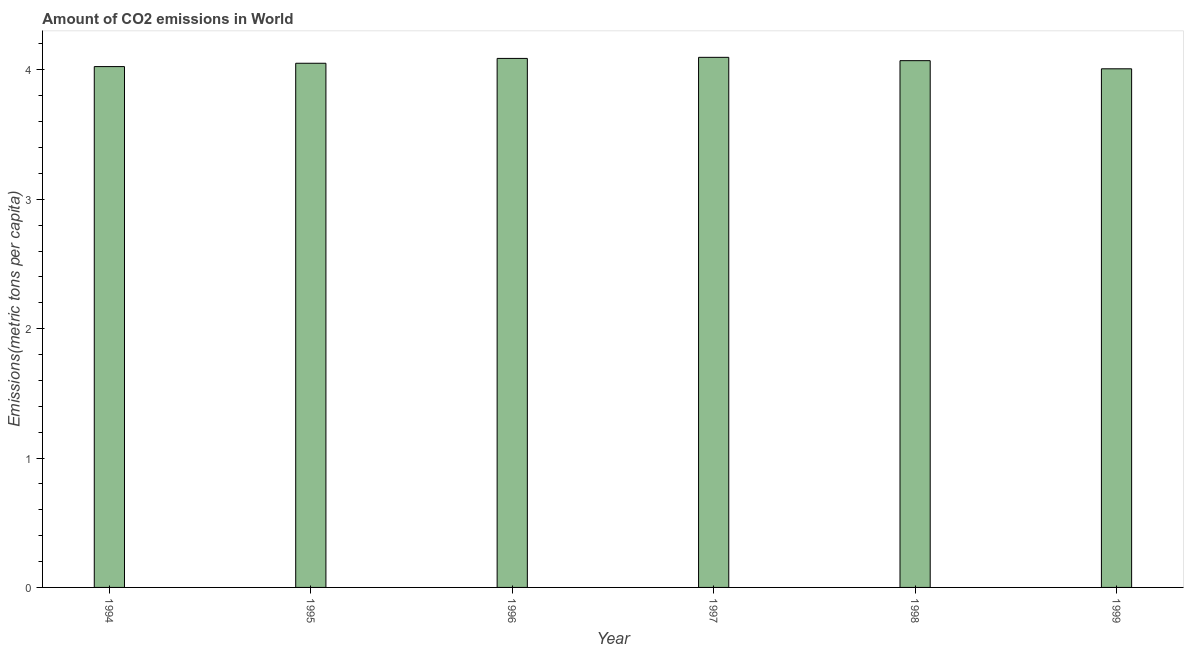Does the graph contain any zero values?
Your answer should be very brief. No. What is the title of the graph?
Give a very brief answer. Amount of CO2 emissions in World. What is the label or title of the X-axis?
Your answer should be compact. Year. What is the label or title of the Y-axis?
Your response must be concise. Emissions(metric tons per capita). What is the amount of co2 emissions in 1995?
Provide a succinct answer. 4.05. Across all years, what is the maximum amount of co2 emissions?
Provide a short and direct response. 4.1. Across all years, what is the minimum amount of co2 emissions?
Ensure brevity in your answer.  4.01. In which year was the amount of co2 emissions maximum?
Provide a short and direct response. 1997. What is the sum of the amount of co2 emissions?
Make the answer very short. 24.34. What is the difference between the amount of co2 emissions in 1994 and 1995?
Ensure brevity in your answer.  -0.03. What is the average amount of co2 emissions per year?
Offer a very short reply. 4.06. What is the median amount of co2 emissions?
Make the answer very short. 4.06. What is the ratio of the amount of co2 emissions in 1996 to that in 1999?
Your answer should be very brief. 1.02. Is the amount of co2 emissions in 1994 less than that in 1996?
Ensure brevity in your answer.  Yes. What is the difference between the highest and the second highest amount of co2 emissions?
Ensure brevity in your answer.  0.01. What is the difference between the highest and the lowest amount of co2 emissions?
Provide a succinct answer. 0.09. In how many years, is the amount of co2 emissions greater than the average amount of co2 emissions taken over all years?
Make the answer very short. 3. How many bars are there?
Keep it short and to the point. 6. What is the difference between two consecutive major ticks on the Y-axis?
Your answer should be very brief. 1. What is the Emissions(metric tons per capita) in 1994?
Ensure brevity in your answer.  4.03. What is the Emissions(metric tons per capita) of 1995?
Provide a succinct answer. 4.05. What is the Emissions(metric tons per capita) in 1996?
Provide a short and direct response. 4.09. What is the Emissions(metric tons per capita) in 1997?
Give a very brief answer. 4.1. What is the Emissions(metric tons per capita) of 1998?
Offer a very short reply. 4.07. What is the Emissions(metric tons per capita) of 1999?
Make the answer very short. 4.01. What is the difference between the Emissions(metric tons per capita) in 1994 and 1995?
Your answer should be very brief. -0.03. What is the difference between the Emissions(metric tons per capita) in 1994 and 1996?
Your answer should be very brief. -0.06. What is the difference between the Emissions(metric tons per capita) in 1994 and 1997?
Offer a terse response. -0.07. What is the difference between the Emissions(metric tons per capita) in 1994 and 1998?
Keep it short and to the point. -0.05. What is the difference between the Emissions(metric tons per capita) in 1994 and 1999?
Give a very brief answer. 0.02. What is the difference between the Emissions(metric tons per capita) in 1995 and 1996?
Give a very brief answer. -0.04. What is the difference between the Emissions(metric tons per capita) in 1995 and 1997?
Your answer should be compact. -0.05. What is the difference between the Emissions(metric tons per capita) in 1995 and 1998?
Your answer should be compact. -0.02. What is the difference between the Emissions(metric tons per capita) in 1995 and 1999?
Make the answer very short. 0.04. What is the difference between the Emissions(metric tons per capita) in 1996 and 1997?
Make the answer very short. -0.01. What is the difference between the Emissions(metric tons per capita) in 1996 and 1998?
Keep it short and to the point. 0.02. What is the difference between the Emissions(metric tons per capita) in 1996 and 1999?
Ensure brevity in your answer.  0.08. What is the difference between the Emissions(metric tons per capita) in 1997 and 1998?
Provide a short and direct response. 0.03. What is the difference between the Emissions(metric tons per capita) in 1997 and 1999?
Your response must be concise. 0.09. What is the difference between the Emissions(metric tons per capita) in 1998 and 1999?
Give a very brief answer. 0.06. What is the ratio of the Emissions(metric tons per capita) in 1994 to that in 1995?
Keep it short and to the point. 0.99. What is the ratio of the Emissions(metric tons per capita) in 1994 to that in 1997?
Provide a short and direct response. 0.98. What is the ratio of the Emissions(metric tons per capita) in 1994 to that in 1998?
Provide a succinct answer. 0.99. What is the ratio of the Emissions(metric tons per capita) in 1994 to that in 1999?
Provide a succinct answer. 1. What is the ratio of the Emissions(metric tons per capita) in 1995 to that in 1996?
Your answer should be very brief. 0.99. What is the ratio of the Emissions(metric tons per capita) in 1995 to that in 1997?
Keep it short and to the point. 0.99. What is the ratio of the Emissions(metric tons per capita) in 1995 to that in 1998?
Offer a very short reply. 0.99. What is the ratio of the Emissions(metric tons per capita) in 1996 to that in 1998?
Provide a short and direct response. 1. What is the ratio of the Emissions(metric tons per capita) in 1996 to that in 1999?
Your answer should be very brief. 1.02. What is the ratio of the Emissions(metric tons per capita) in 1997 to that in 1998?
Ensure brevity in your answer.  1.01. What is the ratio of the Emissions(metric tons per capita) in 1998 to that in 1999?
Your response must be concise. 1.02. 